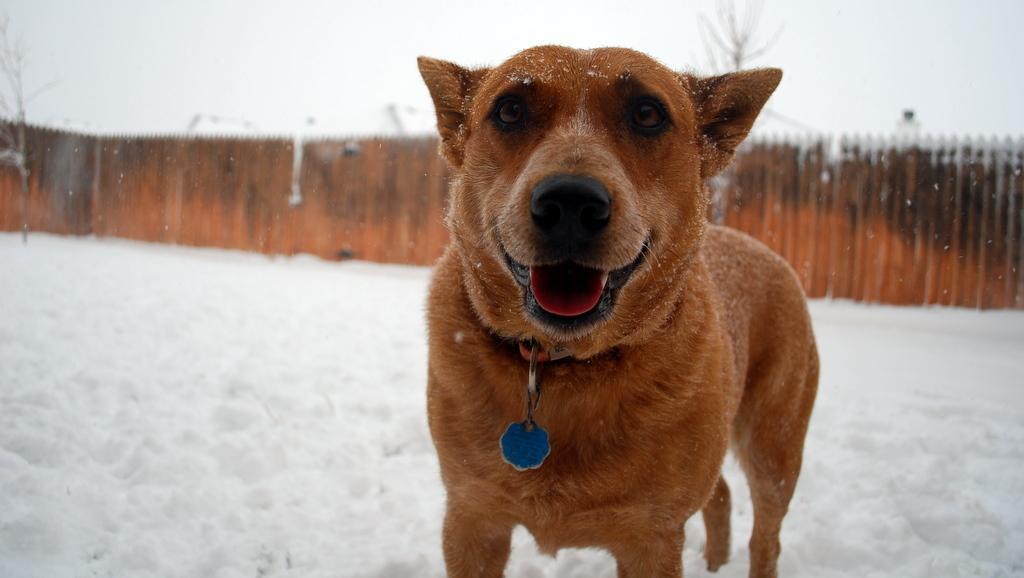In one or two sentences, can you explain what this image depicts? In this image I can see the dog which is in brown color. It is on the snow. In the background I can see the wooden fence, trees and the sky. 